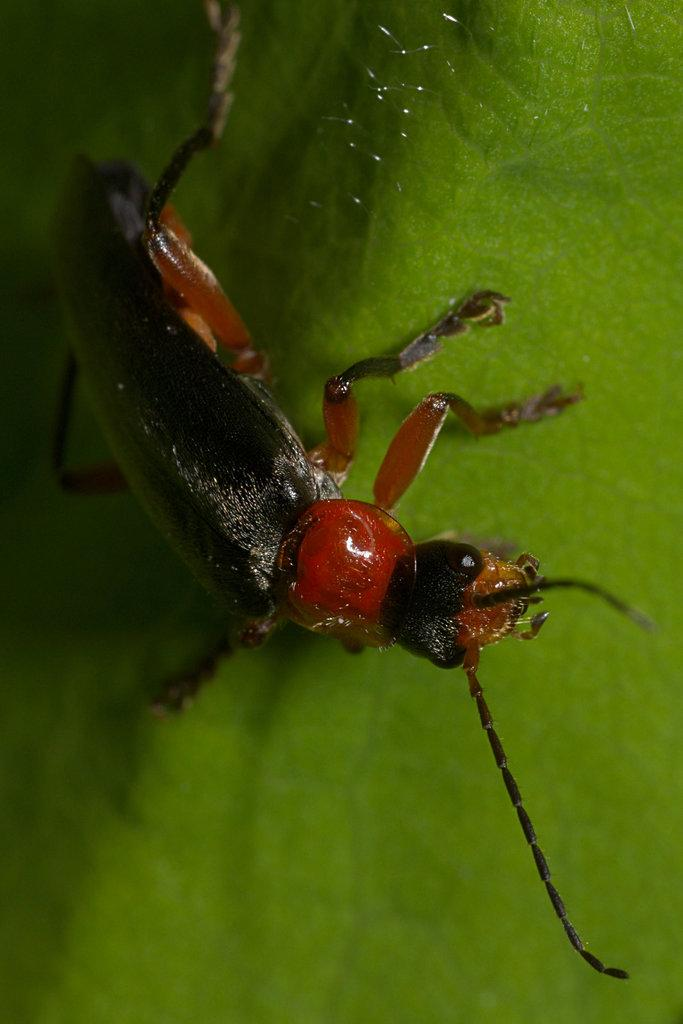What type of creature can be seen in the image? There is an insect in the image. What is the insect situated on in the image? The insect is on a green surface. Where is the baby sleeping in the image? There is no baby present in the image; it only features an insect on a green surface. What type of musical instrument can be seen in the image? There is no musical instrument, such as a guitar, present in the image. 